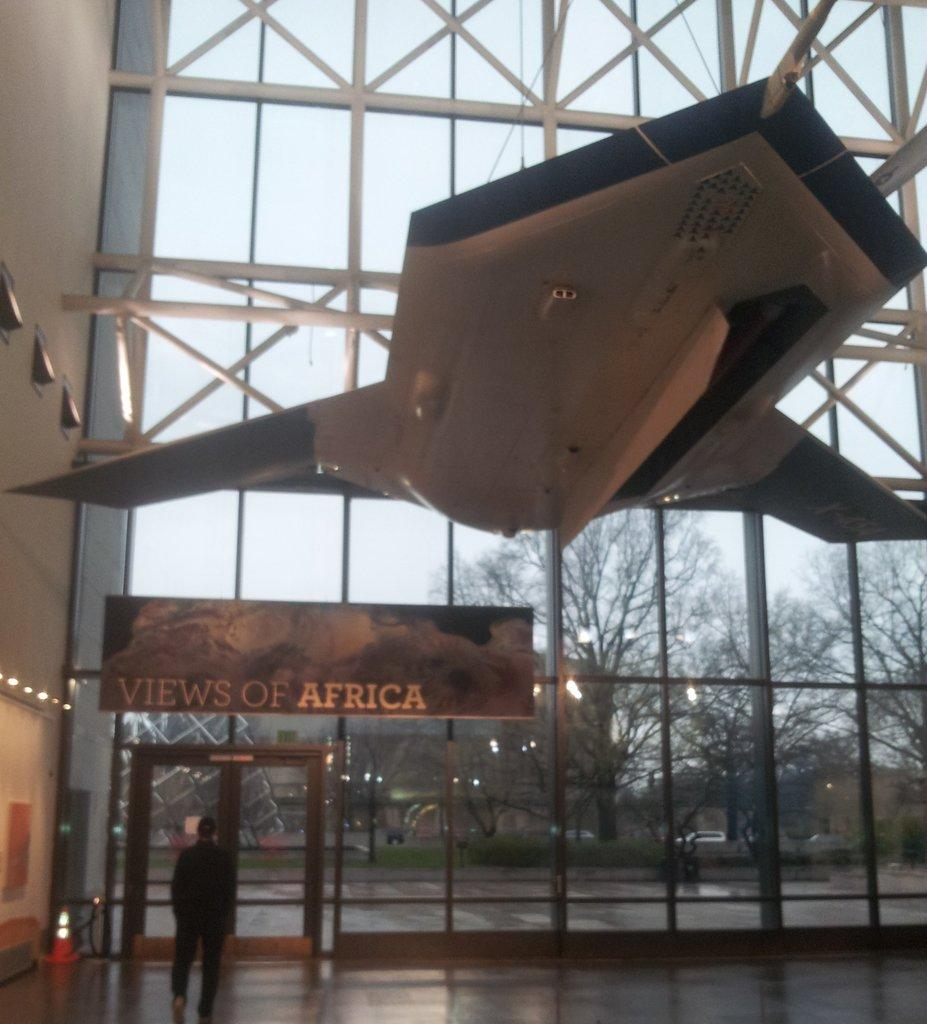<image>
Offer a succinct explanation of the picture presented. A sign on a glass wall that says "VIEWS OF AFRICA" 